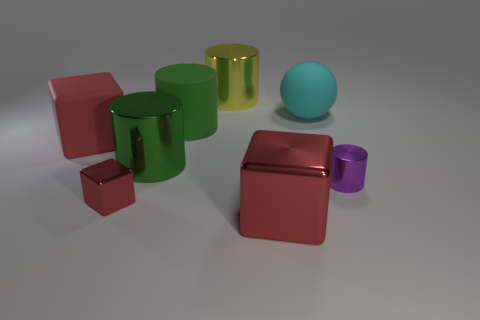Does the purple metal object have the same shape as the cyan object? No, the purple object has a cylindrical shape with a circular base, whereas the cyan object is spherical. Both objects have a distinct geometric form, with the purple cylinder being extended in one dimension, contrasted by the cyan sphere's uniformity in all directions. 